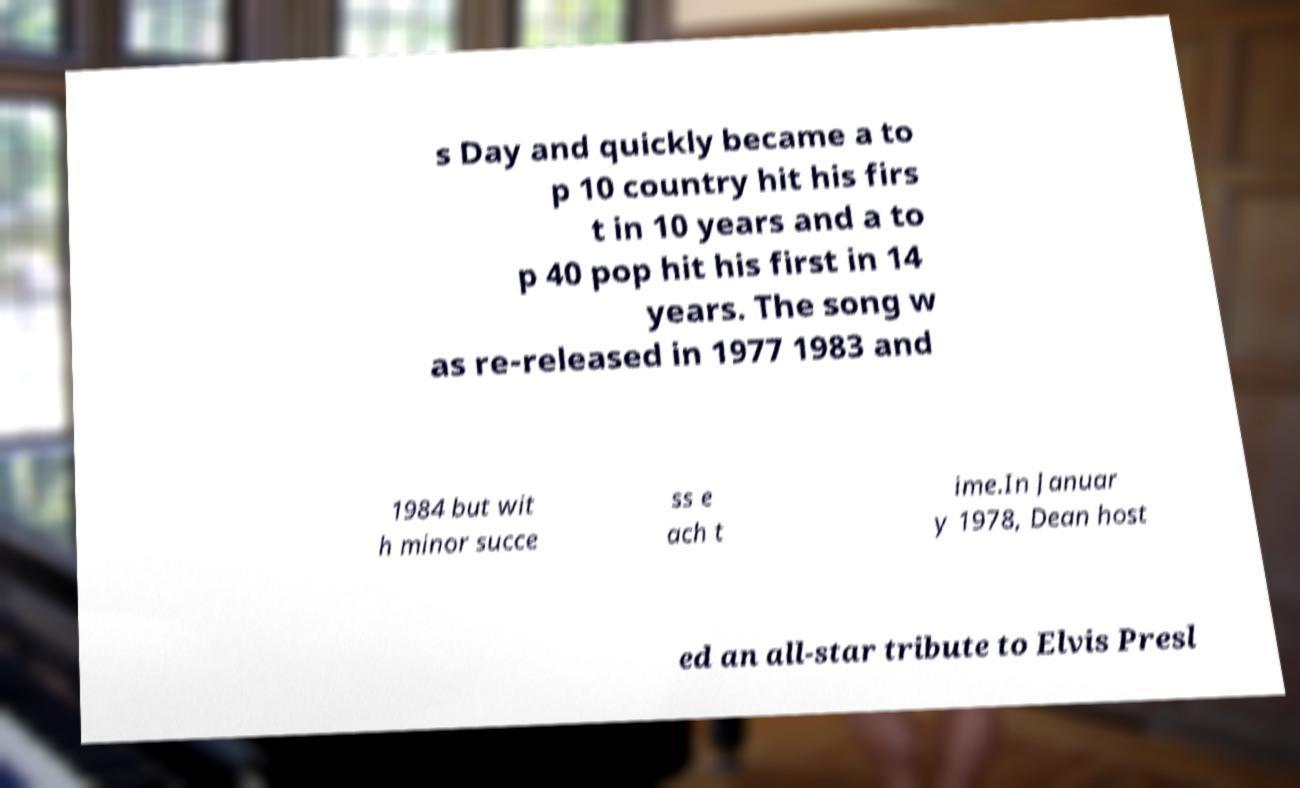For documentation purposes, I need the text within this image transcribed. Could you provide that? s Day and quickly became a to p 10 country hit his firs t in 10 years and a to p 40 pop hit his first in 14 years. The song w as re-released in 1977 1983 and 1984 but wit h minor succe ss e ach t ime.In Januar y 1978, Dean host ed an all-star tribute to Elvis Presl 